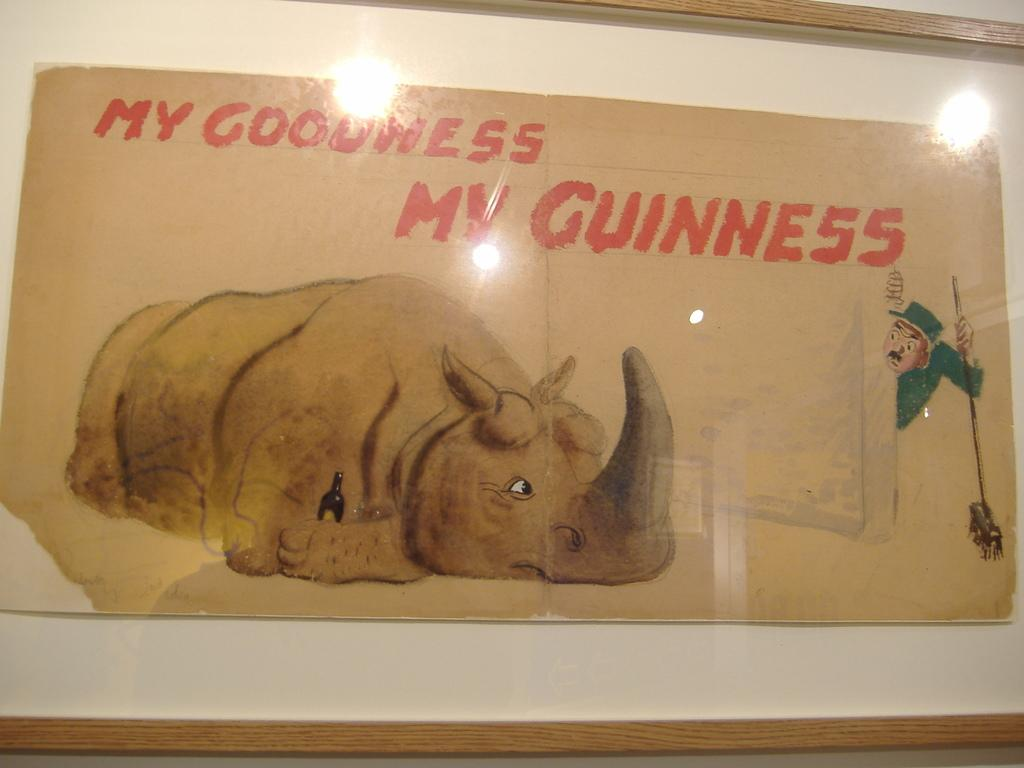What is hanging on the wall in the image? There is a frame on the wall in the image. What is inside the frame? The frame contains text and an image of an animal. How does the animal in the frame transport itself to different locations? The image of the animal in the frame is not a living animal, so it cannot transport itself to different locations. 